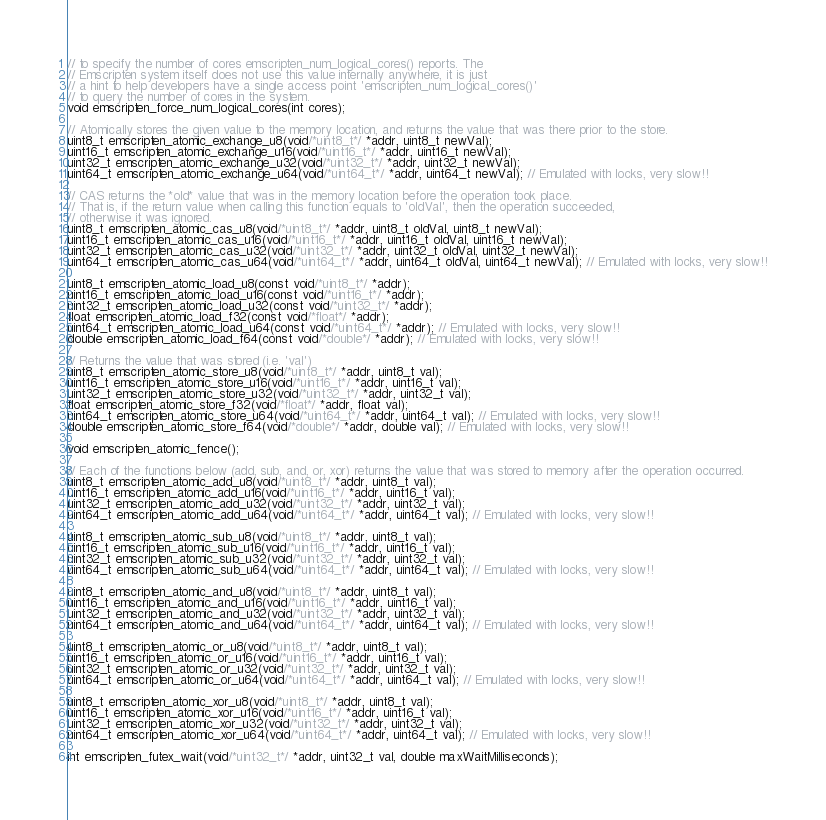<code> <loc_0><loc_0><loc_500><loc_500><_C_>// to specify the number of cores emscripten_num_logical_cores() reports. The
// Emscripten system itself does not use this value internally anywhere, it is just
// a hint to help developers have a single access point 'emscripten_num_logical_cores()'
// to query the number of cores in the system.
void emscripten_force_num_logical_cores(int cores);

// Atomically stores the given value to the memory location, and returns the value that was there prior to the store.
uint8_t emscripten_atomic_exchange_u8(void/*uint8_t*/ *addr, uint8_t newVal);
uint16_t emscripten_atomic_exchange_u16(void/*uint16_t*/ *addr, uint16_t newVal);
uint32_t emscripten_atomic_exchange_u32(void/*uint32_t*/ *addr, uint32_t newVal);
uint64_t emscripten_atomic_exchange_u64(void/*uint64_t*/ *addr, uint64_t newVal); // Emulated with locks, very slow!!

// CAS returns the *old* value that was in the memory location before the operation took place.
// That is, if the return value when calling this function equals to 'oldVal', then the operation succeeded,
// otherwise it was ignored.
uint8_t emscripten_atomic_cas_u8(void/*uint8_t*/ *addr, uint8_t oldVal, uint8_t newVal);
uint16_t emscripten_atomic_cas_u16(void/*uint16_t*/ *addr, uint16_t oldVal, uint16_t newVal);
uint32_t emscripten_atomic_cas_u32(void/*uint32_t*/ *addr, uint32_t oldVal, uint32_t newVal);
uint64_t emscripten_atomic_cas_u64(void/*uint64_t*/ *addr, uint64_t oldVal, uint64_t newVal); // Emulated with locks, very slow!!

uint8_t emscripten_atomic_load_u8(const void/*uint8_t*/ *addr);
uint16_t emscripten_atomic_load_u16(const void/*uint16_t*/ *addr);
uint32_t emscripten_atomic_load_u32(const void/*uint32_t*/ *addr);
float emscripten_atomic_load_f32(const void/*float*/ *addr);
uint64_t emscripten_atomic_load_u64(const void/*uint64_t*/ *addr); // Emulated with locks, very slow!!
double emscripten_atomic_load_f64(const void/*double*/ *addr); // Emulated with locks, very slow!!

// Returns the value that was stored (i.e. 'val')
uint8_t emscripten_atomic_store_u8(void/*uint8_t*/ *addr, uint8_t val);
uint16_t emscripten_atomic_store_u16(void/*uint16_t*/ *addr, uint16_t val);
uint32_t emscripten_atomic_store_u32(void/*uint32_t*/ *addr, uint32_t val);
float emscripten_atomic_store_f32(void/*float*/ *addr, float val);
uint64_t emscripten_atomic_store_u64(void/*uint64_t*/ *addr, uint64_t val); // Emulated with locks, very slow!!
double emscripten_atomic_store_f64(void/*double*/ *addr, double val); // Emulated with locks, very slow!!

void emscripten_atomic_fence();

// Each of the functions below (add, sub, and, or, xor) returns the value that was stored to memory after the operation occurred.
uint8_t emscripten_atomic_add_u8(void/*uint8_t*/ *addr, uint8_t val);
uint16_t emscripten_atomic_add_u16(void/*uint16_t*/ *addr, uint16_t val);
uint32_t emscripten_atomic_add_u32(void/*uint32_t*/ *addr, uint32_t val);
uint64_t emscripten_atomic_add_u64(void/*uint64_t*/ *addr, uint64_t val); // Emulated with locks, very slow!!

uint8_t emscripten_atomic_sub_u8(void/*uint8_t*/ *addr, uint8_t val);
uint16_t emscripten_atomic_sub_u16(void/*uint16_t*/ *addr, uint16_t val);
uint32_t emscripten_atomic_sub_u32(void/*uint32_t*/ *addr, uint32_t val);
uint64_t emscripten_atomic_sub_u64(void/*uint64_t*/ *addr, uint64_t val); // Emulated with locks, very slow!!

uint8_t emscripten_atomic_and_u8(void/*uint8_t*/ *addr, uint8_t val);
uint16_t emscripten_atomic_and_u16(void/*uint16_t*/ *addr, uint16_t val);
uint32_t emscripten_atomic_and_u32(void/*uint32_t*/ *addr, uint32_t val);
uint64_t emscripten_atomic_and_u64(void/*uint64_t*/ *addr, uint64_t val); // Emulated with locks, very slow!!

uint8_t emscripten_atomic_or_u8(void/*uint8_t*/ *addr, uint8_t val);
uint16_t emscripten_atomic_or_u16(void/*uint16_t*/ *addr, uint16_t val);
uint32_t emscripten_atomic_or_u32(void/*uint32_t*/ *addr, uint32_t val);
uint64_t emscripten_atomic_or_u64(void/*uint64_t*/ *addr, uint64_t val); // Emulated with locks, very slow!!

uint8_t emscripten_atomic_xor_u8(void/*uint8_t*/ *addr, uint8_t val);
uint16_t emscripten_atomic_xor_u16(void/*uint16_t*/ *addr, uint16_t val);
uint32_t emscripten_atomic_xor_u32(void/*uint32_t*/ *addr, uint32_t val);
uint64_t emscripten_atomic_xor_u64(void/*uint64_t*/ *addr, uint64_t val); // Emulated with locks, very slow!!

int emscripten_futex_wait(void/*uint32_t*/ *addr, uint32_t val, double maxWaitMilliseconds);</code> 